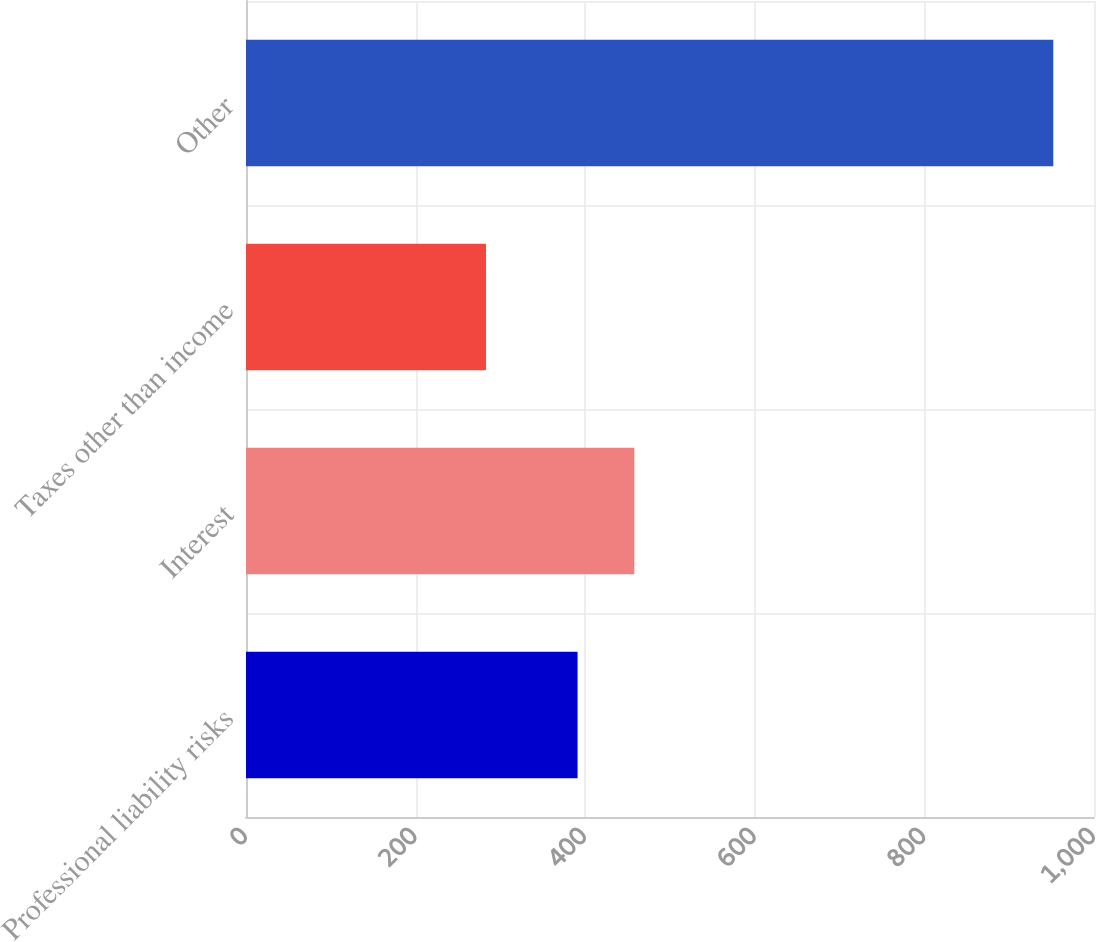<chart> <loc_0><loc_0><loc_500><loc_500><bar_chart><fcel>Professional liability risks<fcel>Interest<fcel>Taxes other than income<fcel>Other<nl><fcel>391<fcel>457.9<fcel>283<fcel>952<nl></chart> 